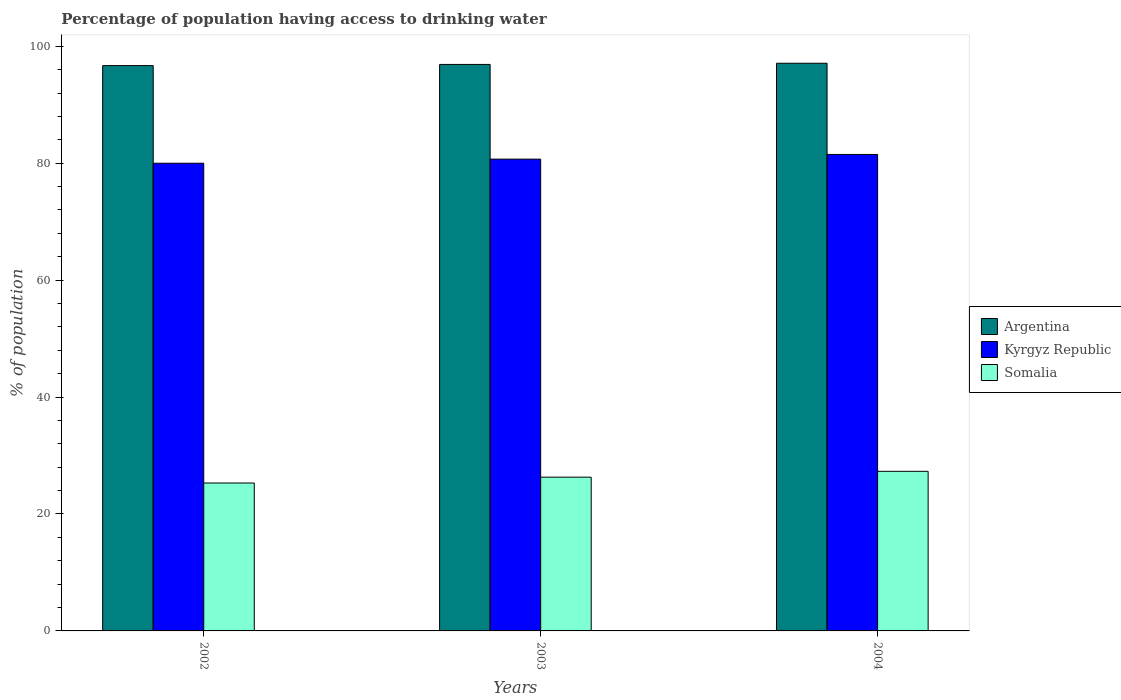How many groups of bars are there?
Offer a very short reply. 3. Are the number of bars on each tick of the X-axis equal?
Your answer should be compact. Yes. What is the percentage of population having access to drinking water in Somalia in 2004?
Provide a succinct answer. 27.3. Across all years, what is the maximum percentage of population having access to drinking water in Kyrgyz Republic?
Keep it short and to the point. 81.5. In which year was the percentage of population having access to drinking water in Argentina maximum?
Offer a terse response. 2004. In which year was the percentage of population having access to drinking water in Somalia minimum?
Provide a short and direct response. 2002. What is the total percentage of population having access to drinking water in Kyrgyz Republic in the graph?
Offer a terse response. 242.2. What is the difference between the percentage of population having access to drinking water in Argentina in 2002 and that in 2004?
Your response must be concise. -0.4. What is the average percentage of population having access to drinking water in Argentina per year?
Provide a short and direct response. 96.9. In the year 2003, what is the difference between the percentage of population having access to drinking water in Argentina and percentage of population having access to drinking water in Kyrgyz Republic?
Give a very brief answer. 16.2. What is the ratio of the percentage of population having access to drinking water in Argentina in 2002 to that in 2004?
Your response must be concise. 1. Is the percentage of population having access to drinking water in Argentina in 2002 less than that in 2004?
Offer a terse response. Yes. Is the difference between the percentage of population having access to drinking water in Argentina in 2002 and 2003 greater than the difference between the percentage of population having access to drinking water in Kyrgyz Republic in 2002 and 2003?
Ensure brevity in your answer.  Yes. What is the difference between the highest and the second highest percentage of population having access to drinking water in Argentina?
Offer a terse response. 0.2. Is the sum of the percentage of population having access to drinking water in Kyrgyz Republic in 2002 and 2003 greater than the maximum percentage of population having access to drinking water in Somalia across all years?
Keep it short and to the point. Yes. What does the 2nd bar from the left in 2004 represents?
Offer a very short reply. Kyrgyz Republic. What does the 2nd bar from the right in 2002 represents?
Your response must be concise. Kyrgyz Republic. Is it the case that in every year, the sum of the percentage of population having access to drinking water in Argentina and percentage of population having access to drinking water in Somalia is greater than the percentage of population having access to drinking water in Kyrgyz Republic?
Keep it short and to the point. Yes. Are all the bars in the graph horizontal?
Offer a terse response. No. Are the values on the major ticks of Y-axis written in scientific E-notation?
Your answer should be compact. No. Does the graph contain grids?
Ensure brevity in your answer.  No. How many legend labels are there?
Your answer should be compact. 3. What is the title of the graph?
Your answer should be very brief. Percentage of population having access to drinking water. Does "Chile" appear as one of the legend labels in the graph?
Your response must be concise. No. What is the label or title of the Y-axis?
Your response must be concise. % of population. What is the % of population of Argentina in 2002?
Provide a short and direct response. 96.7. What is the % of population in Kyrgyz Republic in 2002?
Make the answer very short. 80. What is the % of population of Somalia in 2002?
Offer a very short reply. 25.3. What is the % of population in Argentina in 2003?
Your answer should be very brief. 96.9. What is the % of population in Kyrgyz Republic in 2003?
Ensure brevity in your answer.  80.7. What is the % of population in Somalia in 2003?
Give a very brief answer. 26.3. What is the % of population in Argentina in 2004?
Give a very brief answer. 97.1. What is the % of population of Kyrgyz Republic in 2004?
Your answer should be compact. 81.5. What is the % of population of Somalia in 2004?
Offer a very short reply. 27.3. Across all years, what is the maximum % of population of Argentina?
Provide a short and direct response. 97.1. Across all years, what is the maximum % of population in Kyrgyz Republic?
Provide a succinct answer. 81.5. Across all years, what is the maximum % of population of Somalia?
Offer a terse response. 27.3. Across all years, what is the minimum % of population in Argentina?
Provide a short and direct response. 96.7. Across all years, what is the minimum % of population in Kyrgyz Republic?
Provide a short and direct response. 80. Across all years, what is the minimum % of population in Somalia?
Provide a short and direct response. 25.3. What is the total % of population in Argentina in the graph?
Your answer should be very brief. 290.7. What is the total % of population of Kyrgyz Republic in the graph?
Your response must be concise. 242.2. What is the total % of population in Somalia in the graph?
Provide a succinct answer. 78.9. What is the difference between the % of population of Argentina in 2002 and that in 2003?
Give a very brief answer. -0.2. What is the difference between the % of population of Kyrgyz Republic in 2002 and that in 2003?
Offer a very short reply. -0.7. What is the difference between the % of population in Argentina in 2002 and that in 2004?
Keep it short and to the point. -0.4. What is the difference between the % of population in Argentina in 2003 and that in 2004?
Offer a terse response. -0.2. What is the difference between the % of population in Somalia in 2003 and that in 2004?
Keep it short and to the point. -1. What is the difference between the % of population in Argentina in 2002 and the % of population in Somalia in 2003?
Ensure brevity in your answer.  70.4. What is the difference between the % of population in Kyrgyz Republic in 2002 and the % of population in Somalia in 2003?
Offer a terse response. 53.7. What is the difference between the % of population in Argentina in 2002 and the % of population in Somalia in 2004?
Provide a succinct answer. 69.4. What is the difference between the % of population in Kyrgyz Republic in 2002 and the % of population in Somalia in 2004?
Keep it short and to the point. 52.7. What is the difference between the % of population in Argentina in 2003 and the % of population in Somalia in 2004?
Ensure brevity in your answer.  69.6. What is the difference between the % of population of Kyrgyz Republic in 2003 and the % of population of Somalia in 2004?
Offer a very short reply. 53.4. What is the average % of population of Argentina per year?
Ensure brevity in your answer.  96.9. What is the average % of population of Kyrgyz Republic per year?
Provide a succinct answer. 80.73. What is the average % of population of Somalia per year?
Your response must be concise. 26.3. In the year 2002, what is the difference between the % of population of Argentina and % of population of Kyrgyz Republic?
Ensure brevity in your answer.  16.7. In the year 2002, what is the difference between the % of population in Argentina and % of population in Somalia?
Make the answer very short. 71.4. In the year 2002, what is the difference between the % of population of Kyrgyz Republic and % of population of Somalia?
Offer a very short reply. 54.7. In the year 2003, what is the difference between the % of population in Argentina and % of population in Somalia?
Make the answer very short. 70.6. In the year 2003, what is the difference between the % of population in Kyrgyz Republic and % of population in Somalia?
Offer a very short reply. 54.4. In the year 2004, what is the difference between the % of population of Argentina and % of population of Somalia?
Offer a terse response. 69.8. In the year 2004, what is the difference between the % of population in Kyrgyz Republic and % of population in Somalia?
Provide a succinct answer. 54.2. What is the ratio of the % of population of Argentina in 2002 to that in 2003?
Make the answer very short. 1. What is the ratio of the % of population in Argentina in 2002 to that in 2004?
Give a very brief answer. 1. What is the ratio of the % of population of Kyrgyz Republic in 2002 to that in 2004?
Make the answer very short. 0.98. What is the ratio of the % of population in Somalia in 2002 to that in 2004?
Make the answer very short. 0.93. What is the ratio of the % of population in Argentina in 2003 to that in 2004?
Provide a succinct answer. 1. What is the ratio of the % of population in Kyrgyz Republic in 2003 to that in 2004?
Offer a terse response. 0.99. What is the ratio of the % of population in Somalia in 2003 to that in 2004?
Make the answer very short. 0.96. What is the difference between the highest and the second highest % of population in Somalia?
Your answer should be compact. 1. What is the difference between the highest and the lowest % of population in Kyrgyz Republic?
Provide a succinct answer. 1.5. What is the difference between the highest and the lowest % of population in Somalia?
Offer a terse response. 2. 